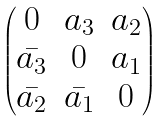Convert formula to latex. <formula><loc_0><loc_0><loc_500><loc_500>\begin{pmatrix} 0 & a _ { 3 } & a _ { 2 } \\ \bar { a _ { 3 } } & 0 & a _ { 1 } \\ \bar { a _ { 2 } } & \bar { a _ { 1 } } & 0 \end{pmatrix}</formula> 